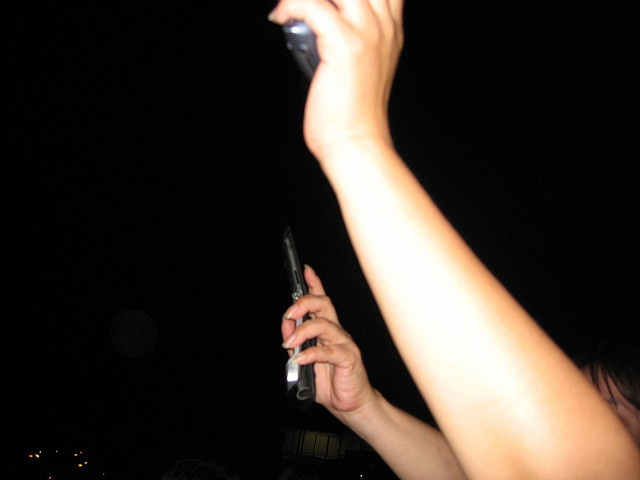Describe the objects in this image and their specific colors. I can see people in black, ivory, and tan tones, cell phone in black, gray, lightgray, and darkgray tones, and cell phone in black, gray, white, and darkgray tones in this image. 